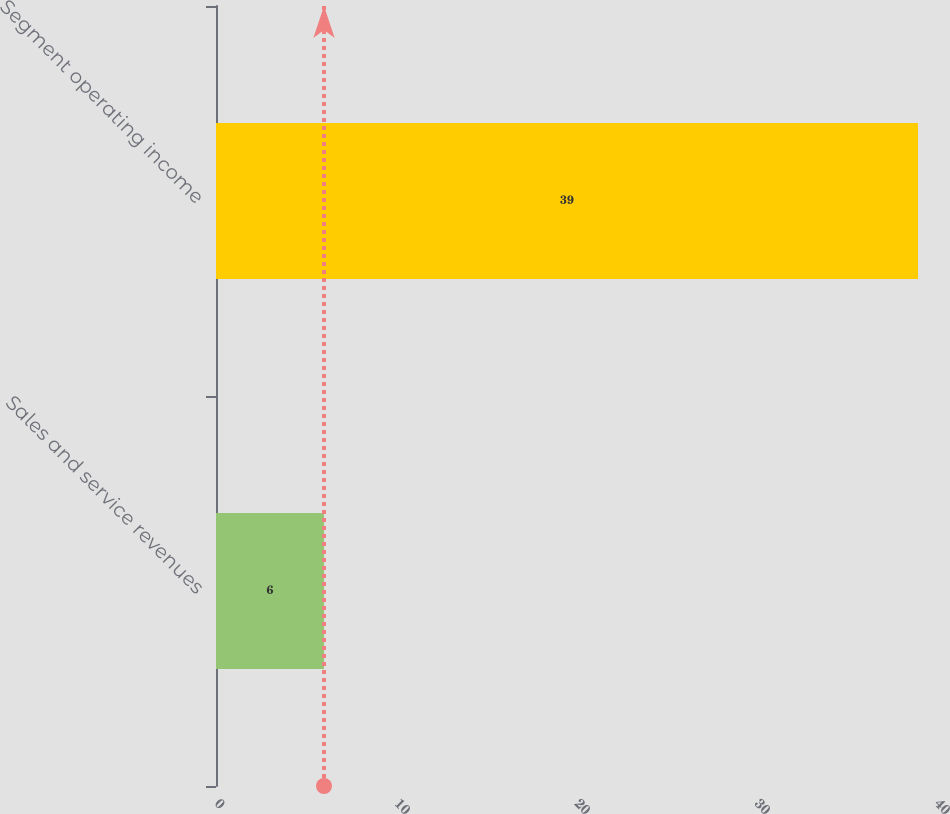<chart> <loc_0><loc_0><loc_500><loc_500><bar_chart><fcel>Sales and service revenues<fcel>Segment operating income<nl><fcel>6<fcel>39<nl></chart> 